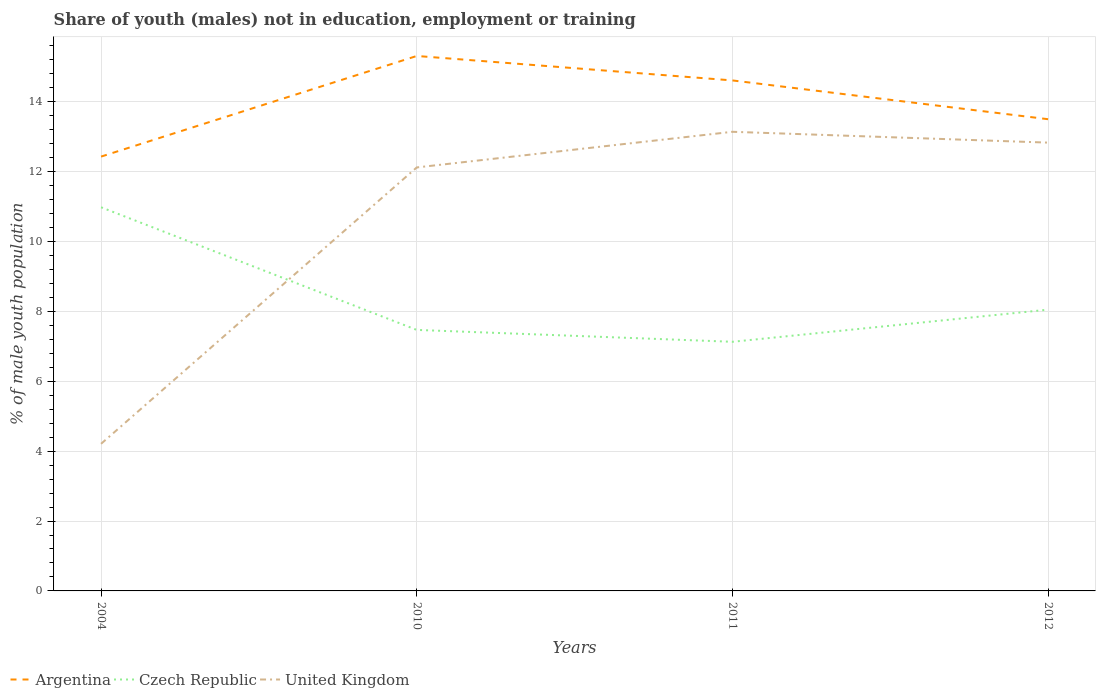How many different coloured lines are there?
Provide a succinct answer. 3. Is the number of lines equal to the number of legend labels?
Provide a short and direct response. Yes. Across all years, what is the maximum percentage of unemployed males population in in United Kingdom?
Give a very brief answer. 4.21. What is the total percentage of unemployed males population in in Argentina in the graph?
Give a very brief answer. -2.88. What is the difference between the highest and the second highest percentage of unemployed males population in in United Kingdom?
Provide a succinct answer. 8.93. Is the percentage of unemployed males population in in Czech Republic strictly greater than the percentage of unemployed males population in in United Kingdom over the years?
Give a very brief answer. No. How many lines are there?
Offer a terse response. 3. How many years are there in the graph?
Give a very brief answer. 4. What is the difference between two consecutive major ticks on the Y-axis?
Your answer should be very brief. 2. Does the graph contain any zero values?
Offer a terse response. No. Does the graph contain grids?
Your answer should be very brief. Yes. How many legend labels are there?
Keep it short and to the point. 3. How are the legend labels stacked?
Ensure brevity in your answer.  Horizontal. What is the title of the graph?
Offer a very short reply. Share of youth (males) not in education, employment or training. What is the label or title of the Y-axis?
Your answer should be compact. % of male youth population. What is the % of male youth population of Argentina in 2004?
Make the answer very short. 12.43. What is the % of male youth population of Czech Republic in 2004?
Provide a short and direct response. 10.98. What is the % of male youth population of United Kingdom in 2004?
Give a very brief answer. 4.21. What is the % of male youth population of Argentina in 2010?
Offer a terse response. 15.31. What is the % of male youth population of Czech Republic in 2010?
Give a very brief answer. 7.47. What is the % of male youth population of United Kingdom in 2010?
Offer a terse response. 12.12. What is the % of male youth population of Argentina in 2011?
Ensure brevity in your answer.  14.61. What is the % of male youth population in Czech Republic in 2011?
Give a very brief answer. 7.13. What is the % of male youth population in United Kingdom in 2011?
Provide a short and direct response. 13.14. What is the % of male youth population in Czech Republic in 2012?
Ensure brevity in your answer.  8.05. What is the % of male youth population of United Kingdom in 2012?
Offer a terse response. 12.83. Across all years, what is the maximum % of male youth population of Argentina?
Offer a very short reply. 15.31. Across all years, what is the maximum % of male youth population in Czech Republic?
Offer a very short reply. 10.98. Across all years, what is the maximum % of male youth population of United Kingdom?
Make the answer very short. 13.14. Across all years, what is the minimum % of male youth population in Argentina?
Your answer should be very brief. 12.43. Across all years, what is the minimum % of male youth population of Czech Republic?
Your answer should be compact. 7.13. Across all years, what is the minimum % of male youth population of United Kingdom?
Give a very brief answer. 4.21. What is the total % of male youth population of Argentina in the graph?
Give a very brief answer. 55.85. What is the total % of male youth population of Czech Republic in the graph?
Give a very brief answer. 33.63. What is the total % of male youth population in United Kingdom in the graph?
Provide a succinct answer. 42.3. What is the difference between the % of male youth population in Argentina in 2004 and that in 2010?
Make the answer very short. -2.88. What is the difference between the % of male youth population of Czech Republic in 2004 and that in 2010?
Your response must be concise. 3.51. What is the difference between the % of male youth population in United Kingdom in 2004 and that in 2010?
Your response must be concise. -7.91. What is the difference between the % of male youth population in Argentina in 2004 and that in 2011?
Provide a short and direct response. -2.18. What is the difference between the % of male youth population in Czech Republic in 2004 and that in 2011?
Give a very brief answer. 3.85. What is the difference between the % of male youth population in United Kingdom in 2004 and that in 2011?
Ensure brevity in your answer.  -8.93. What is the difference between the % of male youth population in Argentina in 2004 and that in 2012?
Offer a terse response. -1.07. What is the difference between the % of male youth population in Czech Republic in 2004 and that in 2012?
Make the answer very short. 2.93. What is the difference between the % of male youth population of United Kingdom in 2004 and that in 2012?
Keep it short and to the point. -8.62. What is the difference between the % of male youth population of Argentina in 2010 and that in 2011?
Ensure brevity in your answer.  0.7. What is the difference between the % of male youth population of Czech Republic in 2010 and that in 2011?
Provide a short and direct response. 0.34. What is the difference between the % of male youth population of United Kingdom in 2010 and that in 2011?
Offer a terse response. -1.02. What is the difference between the % of male youth population in Argentina in 2010 and that in 2012?
Your response must be concise. 1.81. What is the difference between the % of male youth population in Czech Republic in 2010 and that in 2012?
Your answer should be very brief. -0.58. What is the difference between the % of male youth population in United Kingdom in 2010 and that in 2012?
Your answer should be very brief. -0.71. What is the difference between the % of male youth population of Argentina in 2011 and that in 2012?
Your answer should be very brief. 1.11. What is the difference between the % of male youth population in Czech Republic in 2011 and that in 2012?
Offer a terse response. -0.92. What is the difference between the % of male youth population in United Kingdom in 2011 and that in 2012?
Make the answer very short. 0.31. What is the difference between the % of male youth population in Argentina in 2004 and the % of male youth population in Czech Republic in 2010?
Give a very brief answer. 4.96. What is the difference between the % of male youth population in Argentina in 2004 and the % of male youth population in United Kingdom in 2010?
Your answer should be compact. 0.31. What is the difference between the % of male youth population in Czech Republic in 2004 and the % of male youth population in United Kingdom in 2010?
Your answer should be compact. -1.14. What is the difference between the % of male youth population of Argentina in 2004 and the % of male youth population of Czech Republic in 2011?
Offer a terse response. 5.3. What is the difference between the % of male youth population of Argentina in 2004 and the % of male youth population of United Kingdom in 2011?
Your response must be concise. -0.71. What is the difference between the % of male youth population in Czech Republic in 2004 and the % of male youth population in United Kingdom in 2011?
Give a very brief answer. -2.16. What is the difference between the % of male youth population in Argentina in 2004 and the % of male youth population in Czech Republic in 2012?
Your answer should be compact. 4.38. What is the difference between the % of male youth population of Czech Republic in 2004 and the % of male youth population of United Kingdom in 2012?
Offer a very short reply. -1.85. What is the difference between the % of male youth population of Argentina in 2010 and the % of male youth population of Czech Republic in 2011?
Offer a very short reply. 8.18. What is the difference between the % of male youth population of Argentina in 2010 and the % of male youth population of United Kingdom in 2011?
Offer a terse response. 2.17. What is the difference between the % of male youth population in Czech Republic in 2010 and the % of male youth population in United Kingdom in 2011?
Give a very brief answer. -5.67. What is the difference between the % of male youth population in Argentina in 2010 and the % of male youth population in Czech Republic in 2012?
Provide a short and direct response. 7.26. What is the difference between the % of male youth population of Argentina in 2010 and the % of male youth population of United Kingdom in 2012?
Your response must be concise. 2.48. What is the difference between the % of male youth population of Czech Republic in 2010 and the % of male youth population of United Kingdom in 2012?
Make the answer very short. -5.36. What is the difference between the % of male youth population of Argentina in 2011 and the % of male youth population of Czech Republic in 2012?
Offer a very short reply. 6.56. What is the difference between the % of male youth population of Argentina in 2011 and the % of male youth population of United Kingdom in 2012?
Ensure brevity in your answer.  1.78. What is the difference between the % of male youth population in Czech Republic in 2011 and the % of male youth population in United Kingdom in 2012?
Keep it short and to the point. -5.7. What is the average % of male youth population in Argentina per year?
Keep it short and to the point. 13.96. What is the average % of male youth population of Czech Republic per year?
Your answer should be compact. 8.41. What is the average % of male youth population in United Kingdom per year?
Provide a short and direct response. 10.57. In the year 2004, what is the difference between the % of male youth population in Argentina and % of male youth population in Czech Republic?
Offer a very short reply. 1.45. In the year 2004, what is the difference between the % of male youth population in Argentina and % of male youth population in United Kingdom?
Offer a terse response. 8.22. In the year 2004, what is the difference between the % of male youth population of Czech Republic and % of male youth population of United Kingdom?
Make the answer very short. 6.77. In the year 2010, what is the difference between the % of male youth population in Argentina and % of male youth population in Czech Republic?
Keep it short and to the point. 7.84. In the year 2010, what is the difference between the % of male youth population in Argentina and % of male youth population in United Kingdom?
Offer a very short reply. 3.19. In the year 2010, what is the difference between the % of male youth population in Czech Republic and % of male youth population in United Kingdom?
Your answer should be compact. -4.65. In the year 2011, what is the difference between the % of male youth population of Argentina and % of male youth population of Czech Republic?
Offer a very short reply. 7.48. In the year 2011, what is the difference between the % of male youth population in Argentina and % of male youth population in United Kingdom?
Provide a short and direct response. 1.47. In the year 2011, what is the difference between the % of male youth population in Czech Republic and % of male youth population in United Kingdom?
Offer a very short reply. -6.01. In the year 2012, what is the difference between the % of male youth population of Argentina and % of male youth population of Czech Republic?
Make the answer very short. 5.45. In the year 2012, what is the difference between the % of male youth population in Argentina and % of male youth population in United Kingdom?
Make the answer very short. 0.67. In the year 2012, what is the difference between the % of male youth population in Czech Republic and % of male youth population in United Kingdom?
Your answer should be compact. -4.78. What is the ratio of the % of male youth population of Argentina in 2004 to that in 2010?
Provide a succinct answer. 0.81. What is the ratio of the % of male youth population in Czech Republic in 2004 to that in 2010?
Your response must be concise. 1.47. What is the ratio of the % of male youth population of United Kingdom in 2004 to that in 2010?
Give a very brief answer. 0.35. What is the ratio of the % of male youth population of Argentina in 2004 to that in 2011?
Your answer should be very brief. 0.85. What is the ratio of the % of male youth population in Czech Republic in 2004 to that in 2011?
Ensure brevity in your answer.  1.54. What is the ratio of the % of male youth population in United Kingdom in 2004 to that in 2011?
Give a very brief answer. 0.32. What is the ratio of the % of male youth population in Argentina in 2004 to that in 2012?
Provide a short and direct response. 0.92. What is the ratio of the % of male youth population of Czech Republic in 2004 to that in 2012?
Offer a very short reply. 1.36. What is the ratio of the % of male youth population in United Kingdom in 2004 to that in 2012?
Make the answer very short. 0.33. What is the ratio of the % of male youth population of Argentina in 2010 to that in 2011?
Ensure brevity in your answer.  1.05. What is the ratio of the % of male youth population in Czech Republic in 2010 to that in 2011?
Ensure brevity in your answer.  1.05. What is the ratio of the % of male youth population of United Kingdom in 2010 to that in 2011?
Your answer should be compact. 0.92. What is the ratio of the % of male youth population in Argentina in 2010 to that in 2012?
Your response must be concise. 1.13. What is the ratio of the % of male youth population of Czech Republic in 2010 to that in 2012?
Provide a short and direct response. 0.93. What is the ratio of the % of male youth population in United Kingdom in 2010 to that in 2012?
Your response must be concise. 0.94. What is the ratio of the % of male youth population in Argentina in 2011 to that in 2012?
Keep it short and to the point. 1.08. What is the ratio of the % of male youth population of Czech Republic in 2011 to that in 2012?
Offer a very short reply. 0.89. What is the ratio of the % of male youth population in United Kingdom in 2011 to that in 2012?
Give a very brief answer. 1.02. What is the difference between the highest and the second highest % of male youth population in Argentina?
Your answer should be very brief. 0.7. What is the difference between the highest and the second highest % of male youth population of Czech Republic?
Make the answer very short. 2.93. What is the difference between the highest and the second highest % of male youth population of United Kingdom?
Provide a succinct answer. 0.31. What is the difference between the highest and the lowest % of male youth population in Argentina?
Provide a succinct answer. 2.88. What is the difference between the highest and the lowest % of male youth population of Czech Republic?
Ensure brevity in your answer.  3.85. What is the difference between the highest and the lowest % of male youth population of United Kingdom?
Offer a terse response. 8.93. 